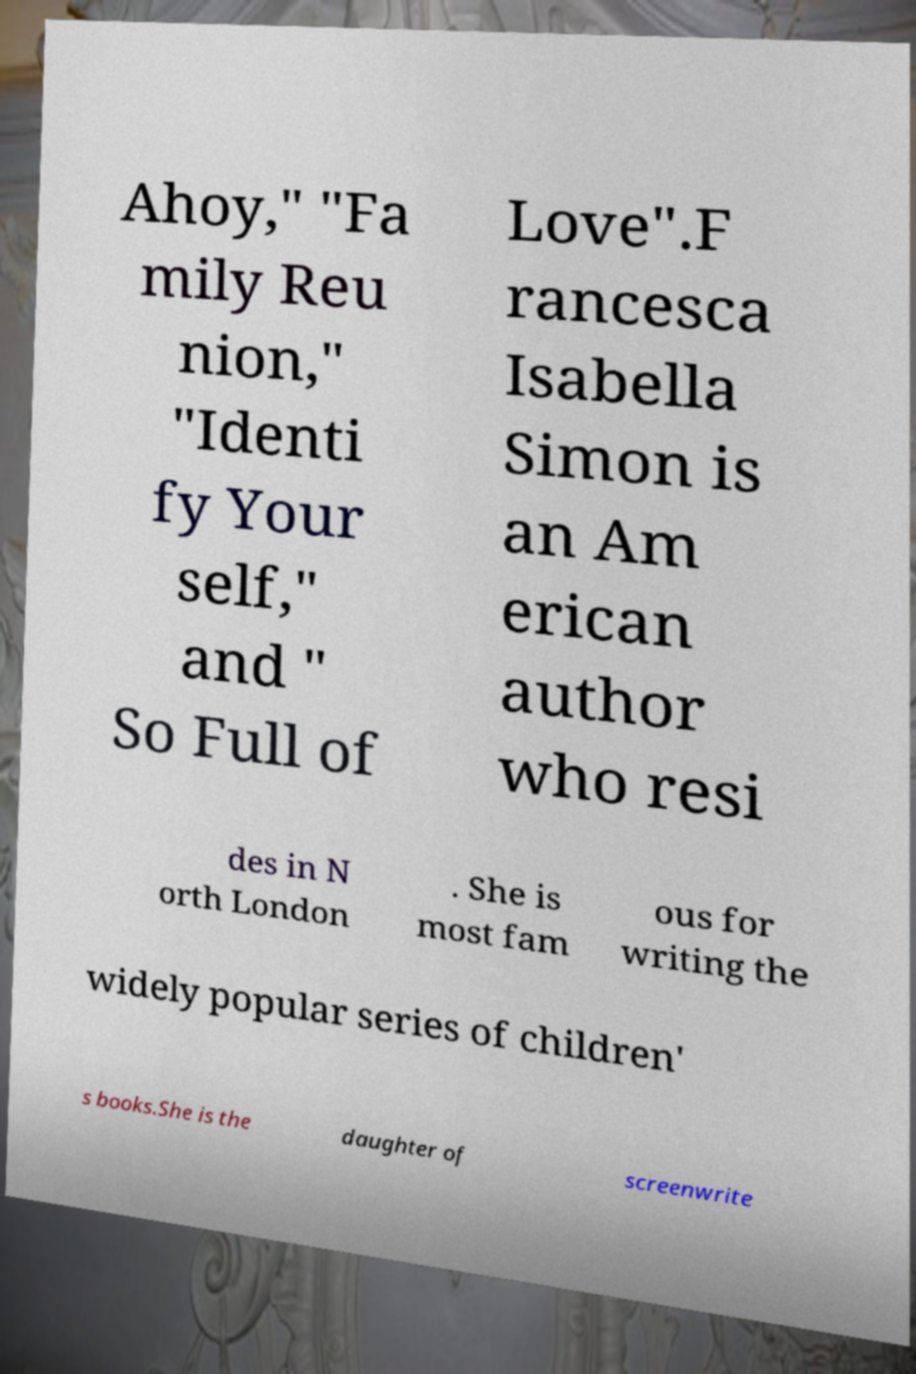I need the written content from this picture converted into text. Can you do that? Ahoy," "Fa mily Reu nion," "Identi fy Your self," and " So Full of Love".F rancesca Isabella Simon is an Am erican author who resi des in N orth London . She is most fam ous for writing the widely popular series of children' s books.She is the daughter of screenwrite 